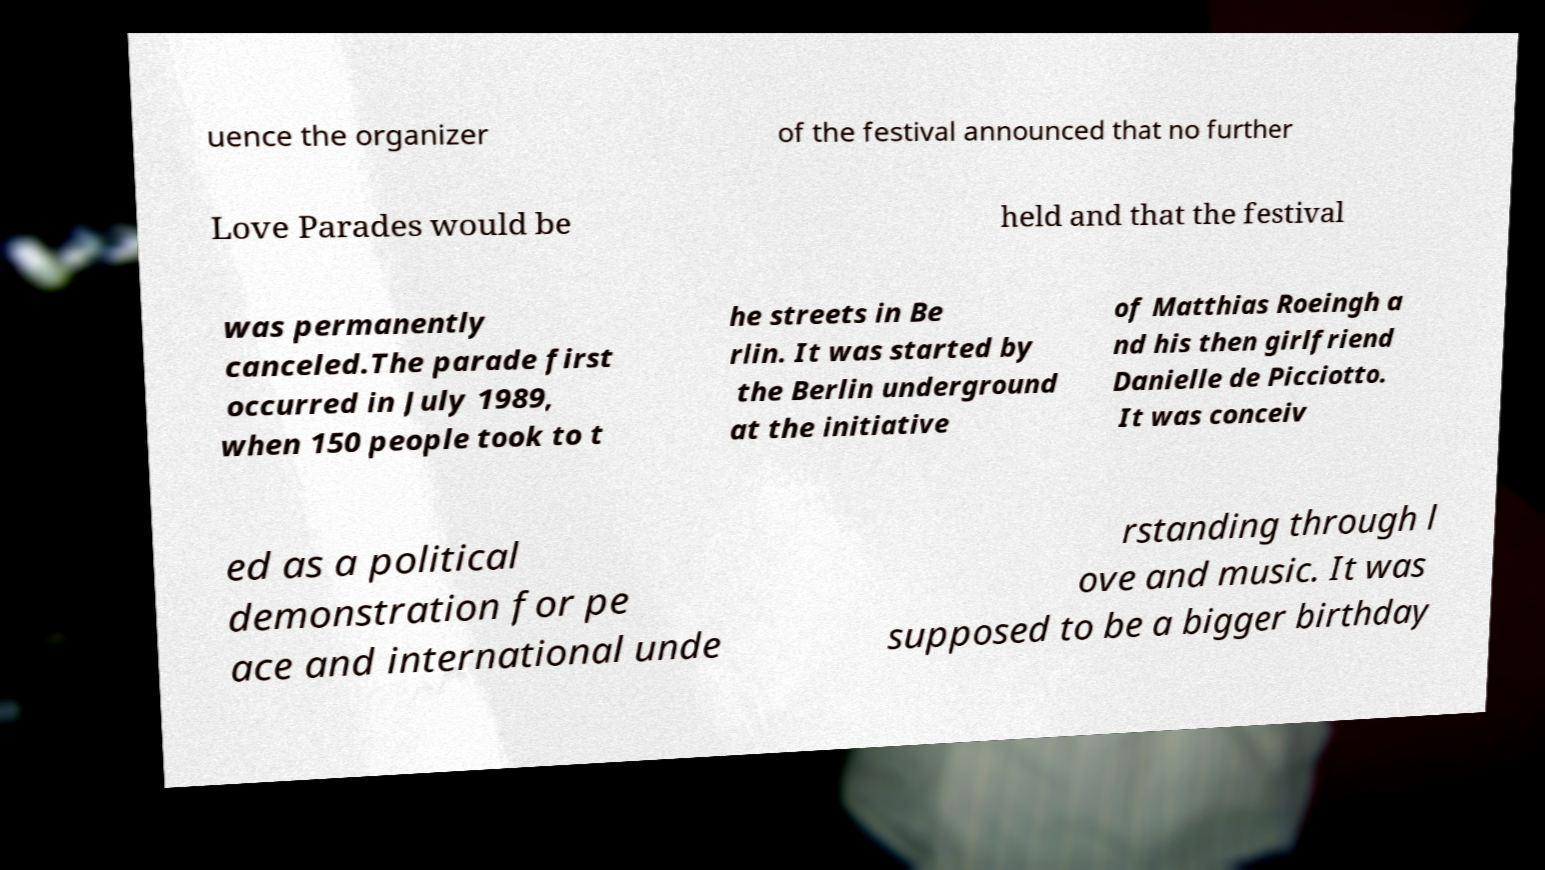For documentation purposes, I need the text within this image transcribed. Could you provide that? uence the organizer of the festival announced that no further Love Parades would be held and that the festival was permanently canceled.The parade first occurred in July 1989, when 150 people took to t he streets in Be rlin. It was started by the Berlin underground at the initiative of Matthias Roeingh a nd his then girlfriend Danielle de Picciotto. It was conceiv ed as a political demonstration for pe ace and international unde rstanding through l ove and music. It was supposed to be a bigger birthday 